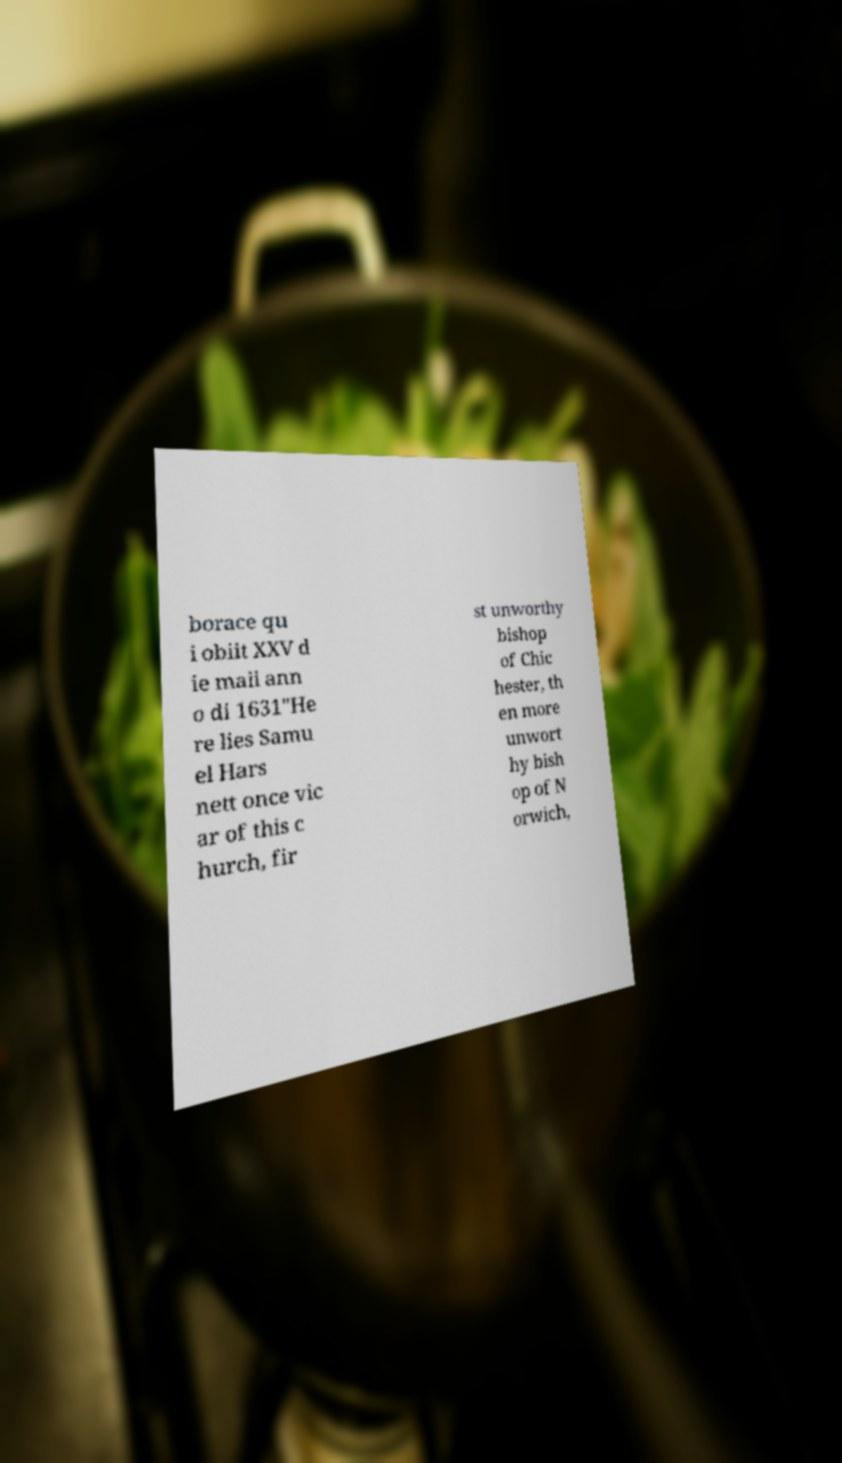What messages or text are displayed in this image? I need them in a readable, typed format. borace qu i obiit XXV d ie maii ann o di 1631"He re lies Samu el Hars nett once vic ar of this c hurch, fir st unworthy bishop of Chic hester, th en more unwort hy bish op of N orwich, 